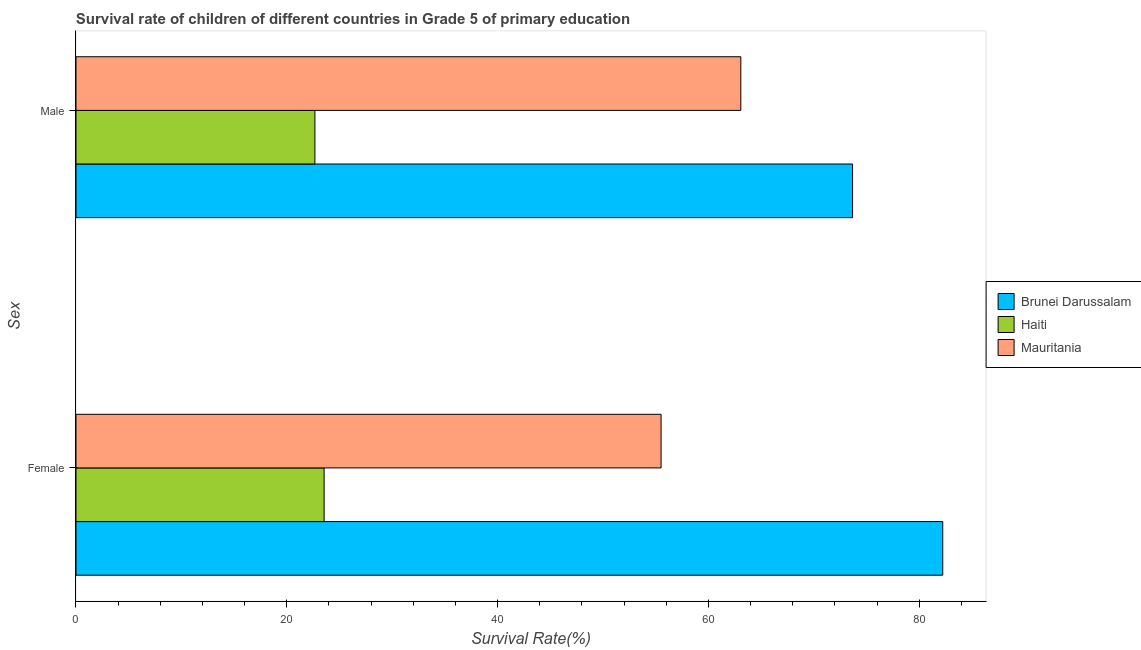How many different coloured bars are there?
Ensure brevity in your answer.  3. How many groups of bars are there?
Offer a very short reply. 2. Are the number of bars on each tick of the Y-axis equal?
Give a very brief answer. Yes. How many bars are there on the 2nd tick from the top?
Provide a succinct answer. 3. What is the label of the 1st group of bars from the top?
Provide a succinct answer. Male. What is the survival rate of male students in primary education in Brunei Darussalam?
Provide a succinct answer. 73.67. Across all countries, what is the maximum survival rate of male students in primary education?
Offer a terse response. 73.67. Across all countries, what is the minimum survival rate of female students in primary education?
Provide a short and direct response. 23.54. In which country was the survival rate of male students in primary education maximum?
Offer a terse response. Brunei Darussalam. In which country was the survival rate of female students in primary education minimum?
Make the answer very short. Haiti. What is the total survival rate of female students in primary education in the graph?
Offer a very short reply. 161.27. What is the difference between the survival rate of female students in primary education in Haiti and that in Brunei Darussalam?
Provide a short and direct response. -58.69. What is the difference between the survival rate of female students in primary education in Brunei Darussalam and the survival rate of male students in primary education in Haiti?
Offer a very short reply. 59.56. What is the average survival rate of male students in primary education per country?
Offer a terse response. 53.13. What is the difference between the survival rate of female students in primary education and survival rate of male students in primary education in Brunei Darussalam?
Your answer should be very brief. 8.56. What is the ratio of the survival rate of male students in primary education in Mauritania to that in Haiti?
Offer a terse response. 2.78. In how many countries, is the survival rate of male students in primary education greater than the average survival rate of male students in primary education taken over all countries?
Provide a short and direct response. 2. What does the 2nd bar from the top in Female represents?
Ensure brevity in your answer.  Haiti. What does the 2nd bar from the bottom in Female represents?
Ensure brevity in your answer.  Haiti. Are all the bars in the graph horizontal?
Your answer should be compact. Yes. Does the graph contain any zero values?
Provide a succinct answer. No. Where does the legend appear in the graph?
Offer a very short reply. Center right. How are the legend labels stacked?
Provide a short and direct response. Vertical. What is the title of the graph?
Provide a succinct answer. Survival rate of children of different countries in Grade 5 of primary education. What is the label or title of the X-axis?
Provide a succinct answer. Survival Rate(%). What is the label or title of the Y-axis?
Give a very brief answer. Sex. What is the Survival Rate(%) in Brunei Darussalam in Female?
Ensure brevity in your answer.  82.23. What is the Survival Rate(%) of Haiti in Female?
Keep it short and to the point. 23.54. What is the Survival Rate(%) in Mauritania in Female?
Provide a short and direct response. 55.51. What is the Survival Rate(%) of Brunei Darussalam in Male?
Provide a succinct answer. 73.67. What is the Survival Rate(%) in Haiti in Male?
Keep it short and to the point. 22.66. What is the Survival Rate(%) of Mauritania in Male?
Your answer should be very brief. 63.07. Across all Sex, what is the maximum Survival Rate(%) of Brunei Darussalam?
Give a very brief answer. 82.23. Across all Sex, what is the maximum Survival Rate(%) in Haiti?
Make the answer very short. 23.54. Across all Sex, what is the maximum Survival Rate(%) of Mauritania?
Offer a very short reply. 63.07. Across all Sex, what is the minimum Survival Rate(%) of Brunei Darussalam?
Your answer should be compact. 73.67. Across all Sex, what is the minimum Survival Rate(%) in Haiti?
Provide a short and direct response. 22.66. Across all Sex, what is the minimum Survival Rate(%) in Mauritania?
Offer a very short reply. 55.51. What is the total Survival Rate(%) of Brunei Darussalam in the graph?
Your answer should be very brief. 155.9. What is the total Survival Rate(%) in Haiti in the graph?
Provide a short and direct response. 46.2. What is the total Survival Rate(%) in Mauritania in the graph?
Keep it short and to the point. 118.58. What is the difference between the Survival Rate(%) in Brunei Darussalam in Female and that in Male?
Provide a succinct answer. 8.56. What is the difference between the Survival Rate(%) of Haiti in Female and that in Male?
Offer a terse response. 0.88. What is the difference between the Survival Rate(%) in Mauritania in Female and that in Male?
Keep it short and to the point. -7.56. What is the difference between the Survival Rate(%) in Brunei Darussalam in Female and the Survival Rate(%) in Haiti in Male?
Make the answer very short. 59.56. What is the difference between the Survival Rate(%) of Brunei Darussalam in Female and the Survival Rate(%) of Mauritania in Male?
Keep it short and to the point. 19.16. What is the difference between the Survival Rate(%) of Haiti in Female and the Survival Rate(%) of Mauritania in Male?
Make the answer very short. -39.53. What is the average Survival Rate(%) in Brunei Darussalam per Sex?
Your response must be concise. 77.95. What is the average Survival Rate(%) of Haiti per Sex?
Your answer should be very brief. 23.1. What is the average Survival Rate(%) of Mauritania per Sex?
Ensure brevity in your answer.  59.29. What is the difference between the Survival Rate(%) in Brunei Darussalam and Survival Rate(%) in Haiti in Female?
Ensure brevity in your answer.  58.69. What is the difference between the Survival Rate(%) in Brunei Darussalam and Survival Rate(%) in Mauritania in Female?
Make the answer very short. 26.72. What is the difference between the Survival Rate(%) of Haiti and Survival Rate(%) of Mauritania in Female?
Give a very brief answer. -31.97. What is the difference between the Survival Rate(%) in Brunei Darussalam and Survival Rate(%) in Haiti in Male?
Give a very brief answer. 51.01. What is the difference between the Survival Rate(%) of Brunei Darussalam and Survival Rate(%) of Mauritania in Male?
Your response must be concise. 10.6. What is the difference between the Survival Rate(%) of Haiti and Survival Rate(%) of Mauritania in Male?
Provide a succinct answer. -40.41. What is the ratio of the Survival Rate(%) in Brunei Darussalam in Female to that in Male?
Give a very brief answer. 1.12. What is the ratio of the Survival Rate(%) in Haiti in Female to that in Male?
Provide a succinct answer. 1.04. What is the ratio of the Survival Rate(%) of Mauritania in Female to that in Male?
Give a very brief answer. 0.88. What is the difference between the highest and the second highest Survival Rate(%) of Brunei Darussalam?
Give a very brief answer. 8.56. What is the difference between the highest and the second highest Survival Rate(%) in Haiti?
Your response must be concise. 0.88. What is the difference between the highest and the second highest Survival Rate(%) in Mauritania?
Keep it short and to the point. 7.56. What is the difference between the highest and the lowest Survival Rate(%) in Brunei Darussalam?
Keep it short and to the point. 8.56. What is the difference between the highest and the lowest Survival Rate(%) in Haiti?
Your response must be concise. 0.88. What is the difference between the highest and the lowest Survival Rate(%) of Mauritania?
Offer a terse response. 7.56. 